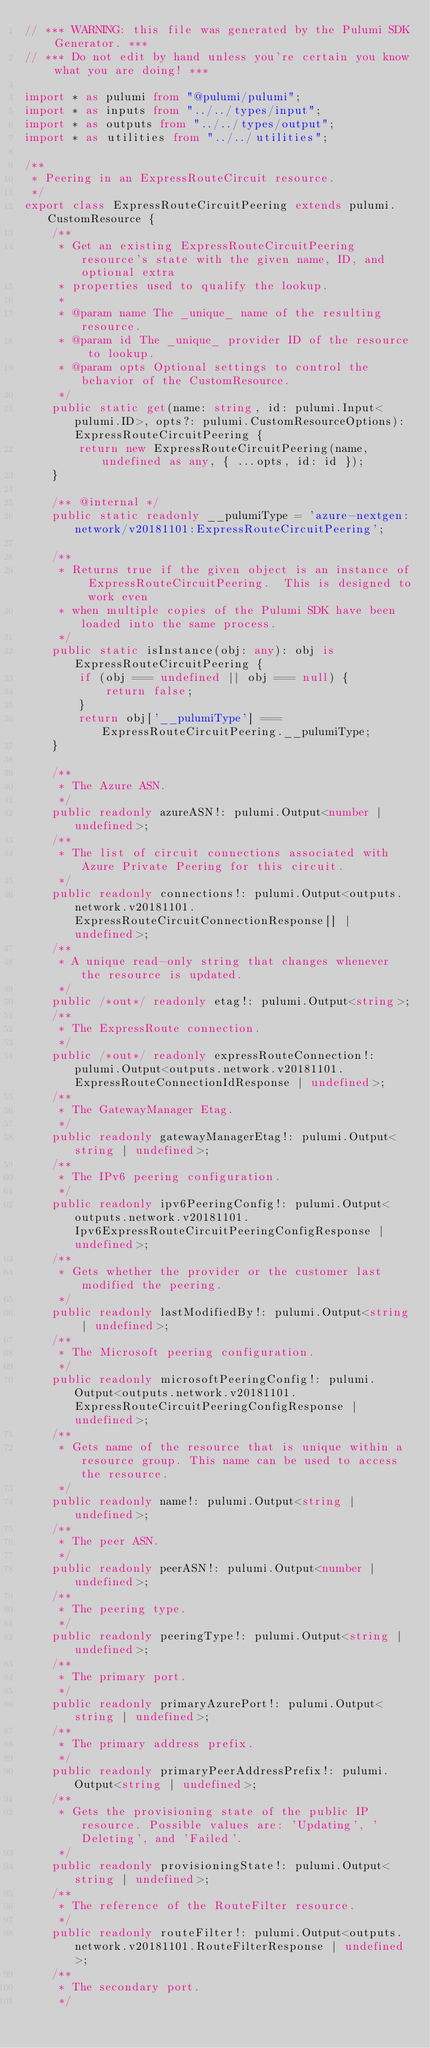<code> <loc_0><loc_0><loc_500><loc_500><_TypeScript_>// *** WARNING: this file was generated by the Pulumi SDK Generator. ***
// *** Do not edit by hand unless you're certain you know what you are doing! ***

import * as pulumi from "@pulumi/pulumi";
import * as inputs from "../../types/input";
import * as outputs from "../../types/output";
import * as utilities from "../../utilities";

/**
 * Peering in an ExpressRouteCircuit resource.
 */
export class ExpressRouteCircuitPeering extends pulumi.CustomResource {
    /**
     * Get an existing ExpressRouteCircuitPeering resource's state with the given name, ID, and optional extra
     * properties used to qualify the lookup.
     *
     * @param name The _unique_ name of the resulting resource.
     * @param id The _unique_ provider ID of the resource to lookup.
     * @param opts Optional settings to control the behavior of the CustomResource.
     */
    public static get(name: string, id: pulumi.Input<pulumi.ID>, opts?: pulumi.CustomResourceOptions): ExpressRouteCircuitPeering {
        return new ExpressRouteCircuitPeering(name, undefined as any, { ...opts, id: id });
    }

    /** @internal */
    public static readonly __pulumiType = 'azure-nextgen:network/v20181101:ExpressRouteCircuitPeering';

    /**
     * Returns true if the given object is an instance of ExpressRouteCircuitPeering.  This is designed to work even
     * when multiple copies of the Pulumi SDK have been loaded into the same process.
     */
    public static isInstance(obj: any): obj is ExpressRouteCircuitPeering {
        if (obj === undefined || obj === null) {
            return false;
        }
        return obj['__pulumiType'] === ExpressRouteCircuitPeering.__pulumiType;
    }

    /**
     * The Azure ASN.
     */
    public readonly azureASN!: pulumi.Output<number | undefined>;
    /**
     * The list of circuit connections associated with Azure Private Peering for this circuit.
     */
    public readonly connections!: pulumi.Output<outputs.network.v20181101.ExpressRouteCircuitConnectionResponse[] | undefined>;
    /**
     * A unique read-only string that changes whenever the resource is updated.
     */
    public /*out*/ readonly etag!: pulumi.Output<string>;
    /**
     * The ExpressRoute connection.
     */
    public /*out*/ readonly expressRouteConnection!: pulumi.Output<outputs.network.v20181101.ExpressRouteConnectionIdResponse | undefined>;
    /**
     * The GatewayManager Etag.
     */
    public readonly gatewayManagerEtag!: pulumi.Output<string | undefined>;
    /**
     * The IPv6 peering configuration.
     */
    public readonly ipv6PeeringConfig!: pulumi.Output<outputs.network.v20181101.Ipv6ExpressRouteCircuitPeeringConfigResponse | undefined>;
    /**
     * Gets whether the provider or the customer last modified the peering.
     */
    public readonly lastModifiedBy!: pulumi.Output<string | undefined>;
    /**
     * The Microsoft peering configuration.
     */
    public readonly microsoftPeeringConfig!: pulumi.Output<outputs.network.v20181101.ExpressRouteCircuitPeeringConfigResponse | undefined>;
    /**
     * Gets name of the resource that is unique within a resource group. This name can be used to access the resource.
     */
    public readonly name!: pulumi.Output<string | undefined>;
    /**
     * The peer ASN.
     */
    public readonly peerASN!: pulumi.Output<number | undefined>;
    /**
     * The peering type.
     */
    public readonly peeringType!: pulumi.Output<string | undefined>;
    /**
     * The primary port.
     */
    public readonly primaryAzurePort!: pulumi.Output<string | undefined>;
    /**
     * The primary address prefix.
     */
    public readonly primaryPeerAddressPrefix!: pulumi.Output<string | undefined>;
    /**
     * Gets the provisioning state of the public IP resource. Possible values are: 'Updating', 'Deleting', and 'Failed'.
     */
    public readonly provisioningState!: pulumi.Output<string | undefined>;
    /**
     * The reference of the RouteFilter resource.
     */
    public readonly routeFilter!: pulumi.Output<outputs.network.v20181101.RouteFilterResponse | undefined>;
    /**
     * The secondary port.
     */</code> 